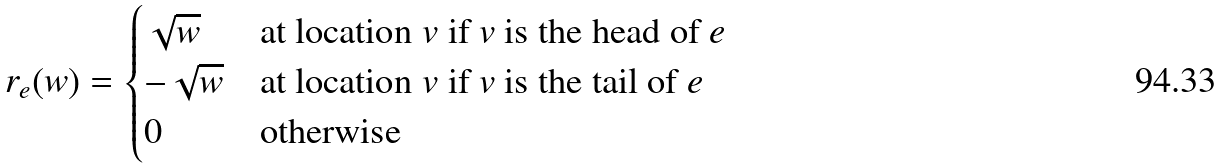Convert formula to latex. <formula><loc_0><loc_0><loc_500><loc_500>r _ { e } ( w ) = \begin{cases} \sqrt { w } & \text {at location $v$ if $v$ is the head of $e$} \\ - \sqrt { w } & \text {at location $v$ if $v$ is the tail of $e$} \\ 0 & \text {otherwise} \\ \end{cases}</formula> 